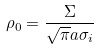<formula> <loc_0><loc_0><loc_500><loc_500>\rho _ { 0 } = \frac { \Sigma } { \sqrt { \pi } a \sigma _ { i } }</formula> 